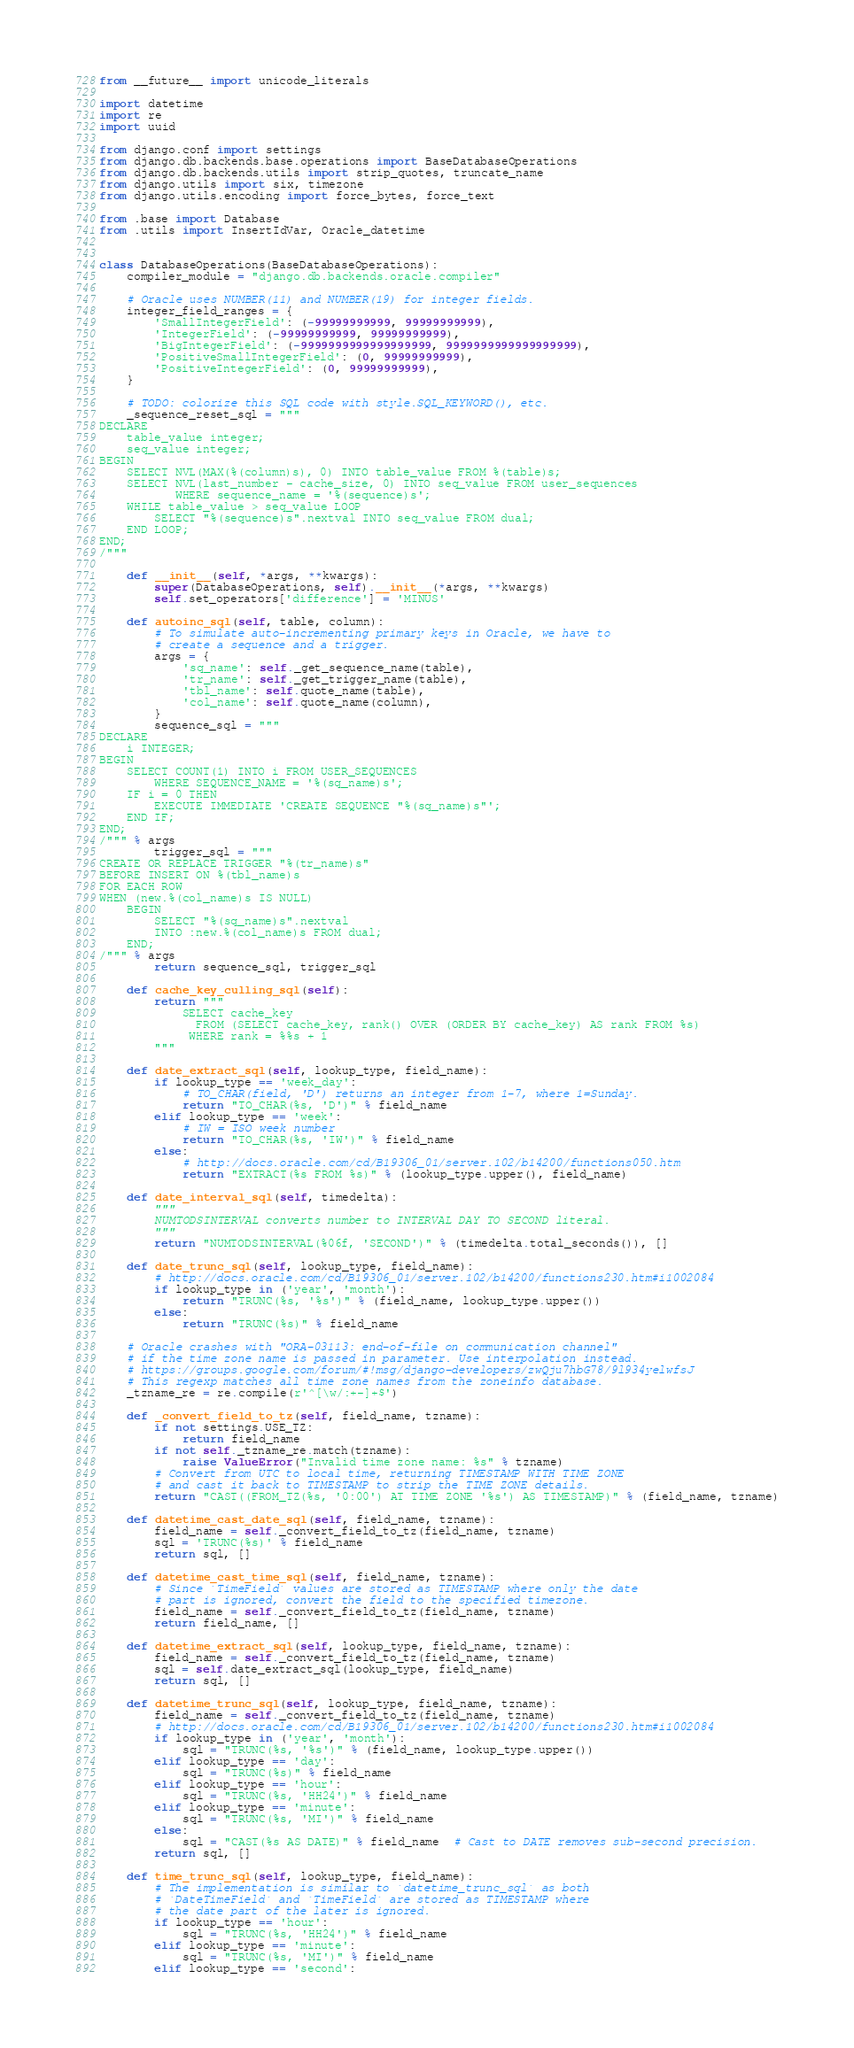<code> <loc_0><loc_0><loc_500><loc_500><_Python_>from __future__ import unicode_literals

import datetime
import re
import uuid

from django.conf import settings
from django.db.backends.base.operations import BaseDatabaseOperations
from django.db.backends.utils import strip_quotes, truncate_name
from django.utils import six, timezone
from django.utils.encoding import force_bytes, force_text

from .base import Database
from .utils import InsertIdVar, Oracle_datetime


class DatabaseOperations(BaseDatabaseOperations):
    compiler_module = "django.db.backends.oracle.compiler"

    # Oracle uses NUMBER(11) and NUMBER(19) for integer fields.
    integer_field_ranges = {
        'SmallIntegerField': (-99999999999, 99999999999),
        'IntegerField': (-99999999999, 99999999999),
        'BigIntegerField': (-9999999999999999999, 9999999999999999999),
        'PositiveSmallIntegerField': (0, 99999999999),
        'PositiveIntegerField': (0, 99999999999),
    }

    # TODO: colorize this SQL code with style.SQL_KEYWORD(), etc.
    _sequence_reset_sql = """
DECLARE
    table_value integer;
    seq_value integer;
BEGIN
    SELECT NVL(MAX(%(column)s), 0) INTO table_value FROM %(table)s;
    SELECT NVL(last_number - cache_size, 0) INTO seq_value FROM user_sequences
           WHERE sequence_name = '%(sequence)s';
    WHILE table_value > seq_value LOOP
        SELECT "%(sequence)s".nextval INTO seq_value FROM dual;
    END LOOP;
END;
/"""

    def __init__(self, *args, **kwargs):
        super(DatabaseOperations, self).__init__(*args, **kwargs)
        self.set_operators['difference'] = 'MINUS'

    def autoinc_sql(self, table, column):
        # To simulate auto-incrementing primary keys in Oracle, we have to
        # create a sequence and a trigger.
        args = {
            'sq_name': self._get_sequence_name(table),
            'tr_name': self._get_trigger_name(table),
            'tbl_name': self.quote_name(table),
            'col_name': self.quote_name(column),
        }
        sequence_sql = """
DECLARE
    i INTEGER;
BEGIN
    SELECT COUNT(1) INTO i FROM USER_SEQUENCES
        WHERE SEQUENCE_NAME = '%(sq_name)s';
    IF i = 0 THEN
        EXECUTE IMMEDIATE 'CREATE SEQUENCE "%(sq_name)s"';
    END IF;
END;
/""" % args
        trigger_sql = """
CREATE OR REPLACE TRIGGER "%(tr_name)s"
BEFORE INSERT ON %(tbl_name)s
FOR EACH ROW
WHEN (new.%(col_name)s IS NULL)
    BEGIN
        SELECT "%(sq_name)s".nextval
        INTO :new.%(col_name)s FROM dual;
    END;
/""" % args
        return sequence_sql, trigger_sql

    def cache_key_culling_sql(self):
        return """
            SELECT cache_key
              FROM (SELECT cache_key, rank() OVER (ORDER BY cache_key) AS rank FROM %s)
             WHERE rank = %%s + 1
        """

    def date_extract_sql(self, lookup_type, field_name):
        if lookup_type == 'week_day':
            # TO_CHAR(field, 'D') returns an integer from 1-7, where 1=Sunday.
            return "TO_CHAR(%s, 'D')" % field_name
        elif lookup_type == 'week':
            # IW = ISO week number
            return "TO_CHAR(%s, 'IW')" % field_name
        else:
            # http://docs.oracle.com/cd/B19306_01/server.102/b14200/functions050.htm
            return "EXTRACT(%s FROM %s)" % (lookup_type.upper(), field_name)

    def date_interval_sql(self, timedelta):
        """
        NUMTODSINTERVAL converts number to INTERVAL DAY TO SECOND literal.
        """
        return "NUMTODSINTERVAL(%06f, 'SECOND')" % (timedelta.total_seconds()), []

    def date_trunc_sql(self, lookup_type, field_name):
        # http://docs.oracle.com/cd/B19306_01/server.102/b14200/functions230.htm#i1002084
        if lookup_type in ('year', 'month'):
            return "TRUNC(%s, '%s')" % (field_name, lookup_type.upper())
        else:
            return "TRUNC(%s)" % field_name

    # Oracle crashes with "ORA-03113: end-of-file on communication channel"
    # if the time zone name is passed in parameter. Use interpolation instead.
    # https://groups.google.com/forum/#!msg/django-developers/zwQju7hbG78/9l934yelwfsJ
    # This regexp matches all time zone names from the zoneinfo database.
    _tzname_re = re.compile(r'^[\w/:+-]+$')

    def _convert_field_to_tz(self, field_name, tzname):
        if not settings.USE_TZ:
            return field_name
        if not self._tzname_re.match(tzname):
            raise ValueError("Invalid time zone name: %s" % tzname)
        # Convert from UTC to local time, returning TIMESTAMP WITH TIME ZONE
        # and cast it back to TIMESTAMP to strip the TIME ZONE details.
        return "CAST((FROM_TZ(%s, '0:00') AT TIME ZONE '%s') AS TIMESTAMP)" % (field_name, tzname)

    def datetime_cast_date_sql(self, field_name, tzname):
        field_name = self._convert_field_to_tz(field_name, tzname)
        sql = 'TRUNC(%s)' % field_name
        return sql, []

    def datetime_cast_time_sql(self, field_name, tzname):
        # Since `TimeField` values are stored as TIMESTAMP where only the date
        # part is ignored, convert the field to the specified timezone.
        field_name = self._convert_field_to_tz(field_name, tzname)
        return field_name, []

    def datetime_extract_sql(self, lookup_type, field_name, tzname):
        field_name = self._convert_field_to_tz(field_name, tzname)
        sql = self.date_extract_sql(lookup_type, field_name)
        return sql, []

    def datetime_trunc_sql(self, lookup_type, field_name, tzname):
        field_name = self._convert_field_to_tz(field_name, tzname)
        # http://docs.oracle.com/cd/B19306_01/server.102/b14200/functions230.htm#i1002084
        if lookup_type in ('year', 'month'):
            sql = "TRUNC(%s, '%s')" % (field_name, lookup_type.upper())
        elif lookup_type == 'day':
            sql = "TRUNC(%s)" % field_name
        elif lookup_type == 'hour':
            sql = "TRUNC(%s, 'HH24')" % field_name
        elif lookup_type == 'minute':
            sql = "TRUNC(%s, 'MI')" % field_name
        else:
            sql = "CAST(%s AS DATE)" % field_name  # Cast to DATE removes sub-second precision.
        return sql, []

    def time_trunc_sql(self, lookup_type, field_name):
        # The implementation is similar to `datetime_trunc_sql` as both
        # `DateTimeField` and `TimeField` are stored as TIMESTAMP where
        # the date part of the later is ignored.
        if lookup_type == 'hour':
            sql = "TRUNC(%s, 'HH24')" % field_name
        elif lookup_type == 'minute':
            sql = "TRUNC(%s, 'MI')" % field_name
        elif lookup_type == 'second':</code> 